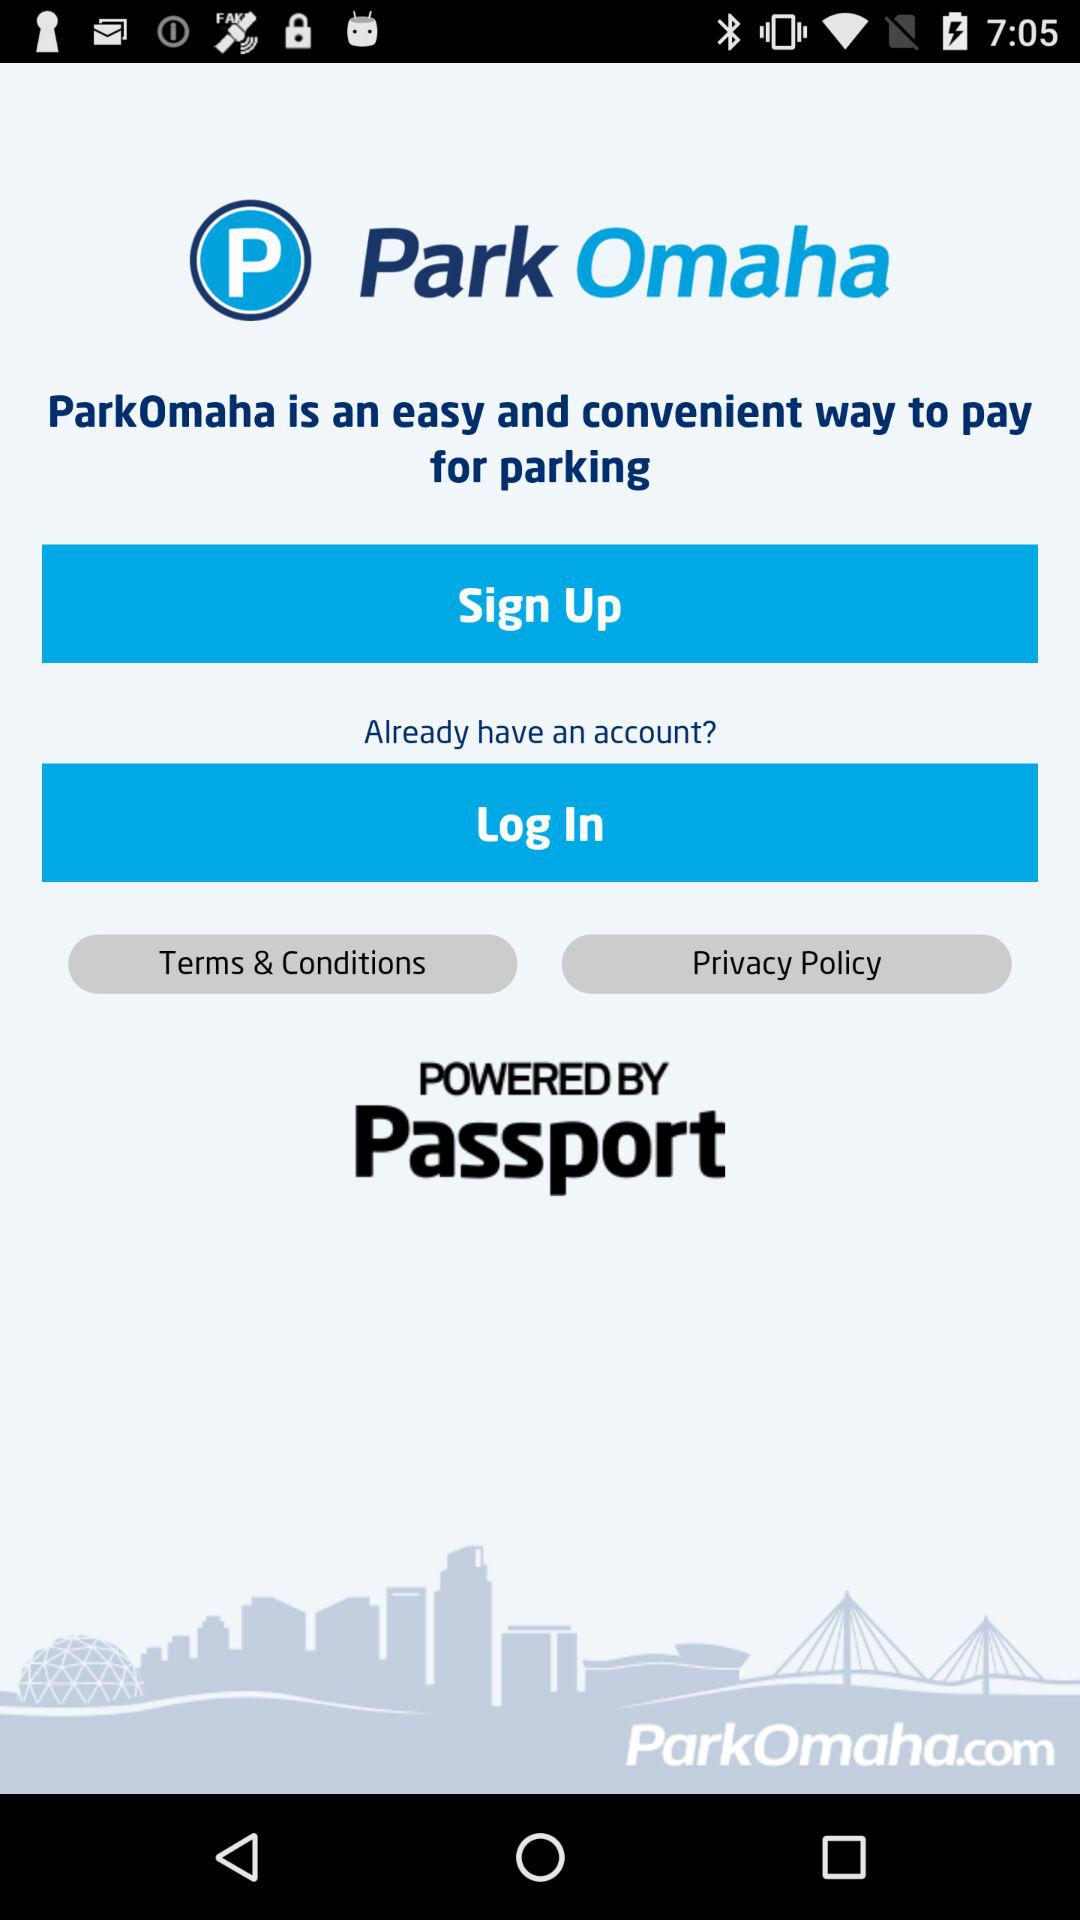What is the application name? The application name is "Park Omaha". 